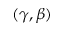<formula> <loc_0><loc_0><loc_500><loc_500>( \gamma , \beta )</formula> 